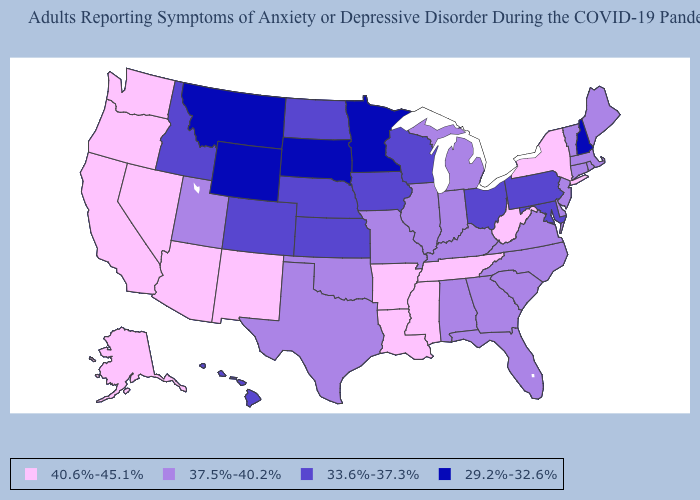Does Kansas have a lower value than Oklahoma?
Concise answer only. Yes. Does Alaska have the highest value in the USA?
Answer briefly. Yes. What is the highest value in the USA?
Give a very brief answer. 40.6%-45.1%. Among the states that border West Virginia , which have the highest value?
Write a very short answer. Kentucky, Virginia. What is the highest value in states that border Idaho?
Short answer required. 40.6%-45.1%. What is the highest value in the USA?
Be succinct. 40.6%-45.1%. Which states have the highest value in the USA?
Answer briefly. Alaska, Arizona, Arkansas, California, Louisiana, Mississippi, Nevada, New Mexico, New York, Oregon, Tennessee, Washington, West Virginia. Among the states that border Massachusetts , which have the lowest value?
Quick response, please. New Hampshire. Name the states that have a value in the range 40.6%-45.1%?
Keep it brief. Alaska, Arizona, Arkansas, California, Louisiana, Mississippi, Nevada, New Mexico, New York, Oregon, Tennessee, Washington, West Virginia. Among the states that border Rhode Island , which have the highest value?
Be succinct. Connecticut, Massachusetts. Is the legend a continuous bar?
Short answer required. No. What is the lowest value in states that border Idaho?
Write a very short answer. 29.2%-32.6%. What is the value of Texas?
Keep it brief. 37.5%-40.2%. Among the states that border Nevada , does Oregon have the lowest value?
Quick response, please. No. Does Michigan have the highest value in the MidWest?
Concise answer only. Yes. 